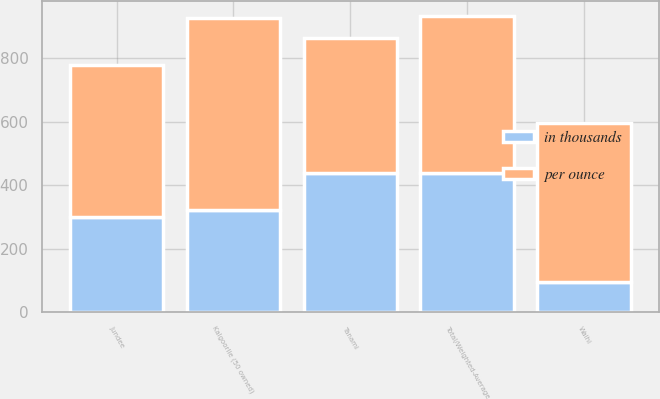<chart> <loc_0><loc_0><loc_500><loc_500><stacked_bar_chart><ecel><fcel>Tanami<fcel>Kalgoorlie (50 owned)<fcel>Jundee<fcel>Waihi<fcel>Total/Weighted-Average<nl><fcel>in thousands<fcel>439<fcel>323<fcel>298<fcel>93<fcel>439<nl><fcel>per ounce<fcel>425<fcel>605<fcel>480<fcel>502<fcel>496<nl></chart> 